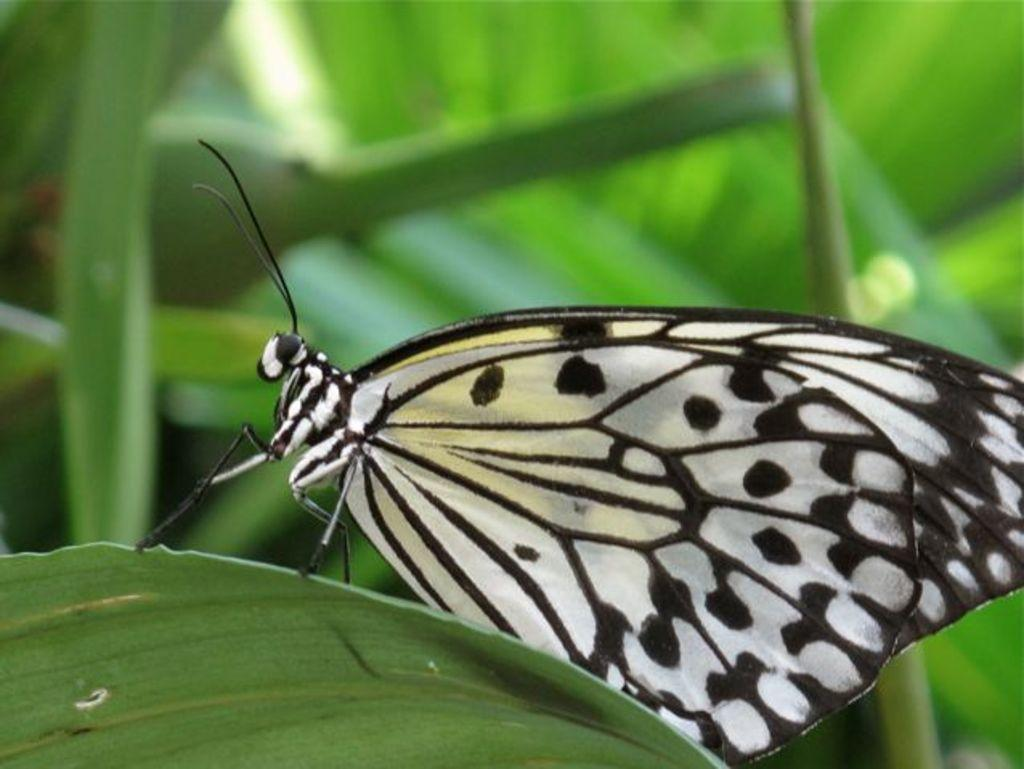What is the main subject of the image? There is a butterfly in the image. Where is the butterfly located? The butterfly is on a leaf. Can you describe the background of the image? The background of the image is blurred. What position does the butterfly hold while writing in the image? There is no writing or indication of a writing position in the image, as it features a butterfly on a leaf with a blurred background. 